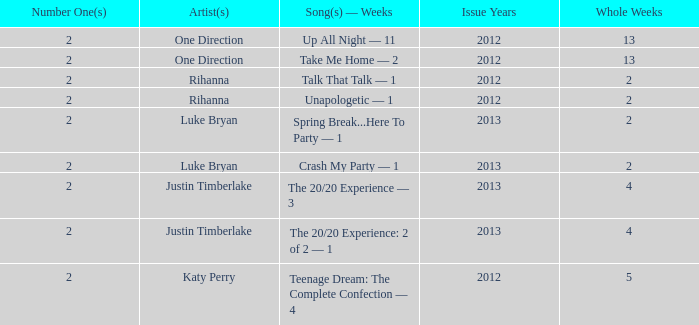What is the maximum number of weeks a single song has stayed at the #1 position? 13.0. 